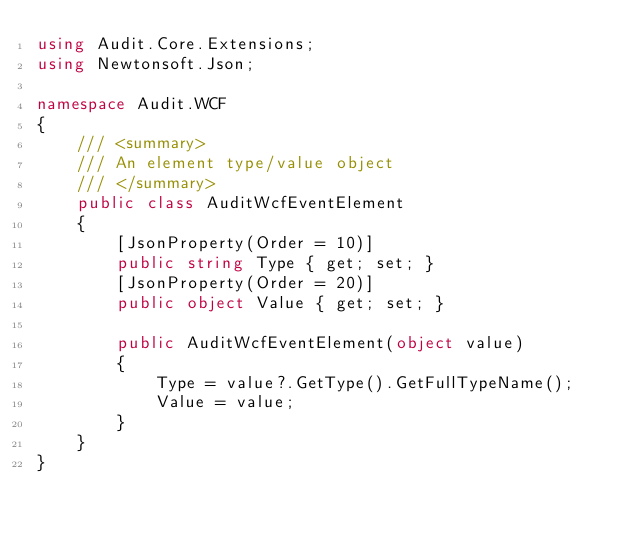<code> <loc_0><loc_0><loc_500><loc_500><_C#_>using Audit.Core.Extensions;
using Newtonsoft.Json;

namespace Audit.WCF
{
    /// <summary>
    /// An element type/value object
    /// </summary>
    public class AuditWcfEventElement
    {
        [JsonProperty(Order = 10)]
        public string Type { get; set; }
        [JsonProperty(Order = 20)]
        public object Value { get; set; }

        public AuditWcfEventElement(object value)
        {
            Type = value?.GetType().GetFullTypeName();
            Value = value;
        }
    }
}</code> 